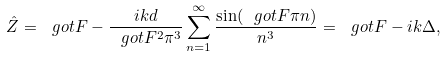<formula> <loc_0><loc_0><loc_500><loc_500>\hat { Z } = \ g o t { F } - \frac { i k d } { \ g o t { F } ^ { 2 } \pi ^ { 3 } } \sum _ { n = 1 } ^ { \infty } \frac { \sin ( \ g o t { F } \pi n ) } { n ^ { 3 } } = \ g o t { F } - i k \Delta ,</formula> 